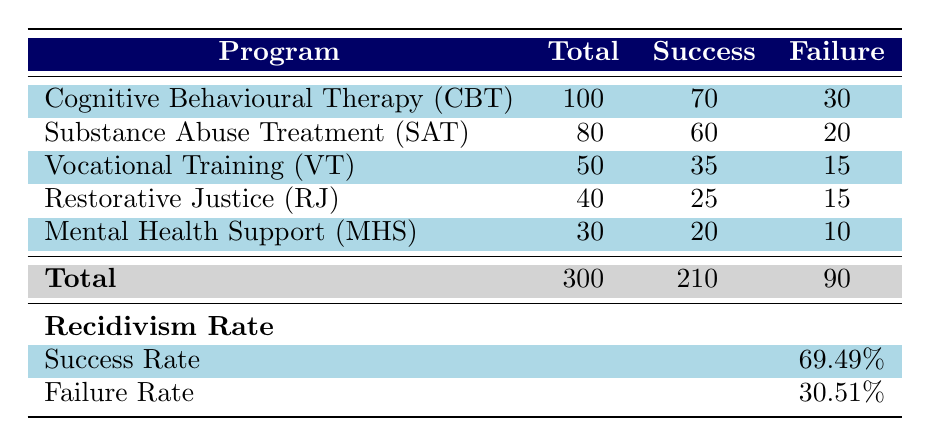What is the total number of participants across all programs? To find the total number of participants, we need to sum the 'Total' values from each program: 100 (CBT) + 80 (SAT) + 50 (VT) + 40 (RJ) + 30 (MHS) = 300.
Answer: 300 Which program had the highest success rate? To determine the highest success rate, we calculate success rates for each program: CBT (70/100 = 70%), SAT (60/80 = 75%), VT (35/50 = 70%), RJ (25/40 = 62.5%), MHS (20/30 = 66.67%). The highest success rate is SAT at 75%.
Answer: SAT Is the failure rate lower than 30% for any program? We can check the failure rates for each program: CBT (30%), SAT (25%), VT (30%), RJ (37.5%), MHS (33.33%). Since SAT is the only program below 30%, the answer is yes.
Answer: Yes What is the average number of successes per program? To find the average success per program, sum the 'Success' values: 70 + 60 + 35 + 25 + 20 = 210, and divide by the number of programs (5), resulting in 210/5 = 42.
Answer: 42 How many more participants were there in CBT compared to MHS? The number of participants in CBT is 100 and in MHS is 30. The difference is 100 - 30 = 70 participants more in CBT.
Answer: 70 Did Restorative Justice (RJ) have more failures than successes? RJ had 25 successes and 15 failures. Since 15 is less than 25, RJ did not have more failures than successes.
Answer: No What is the overall success rate across all programs? The overall success rate is calculated by dividing total success (205) by total participants (295) and multiplying by 100, which results in (205/295) * 100 = 69.49%.
Answer: 69.49% Which program has the lowest total number of participants? Looking at the 'Total' values, Mental Health Support (MHS) has the lowest number with 30 participants.
Answer: Mental Health Support (MHS) 